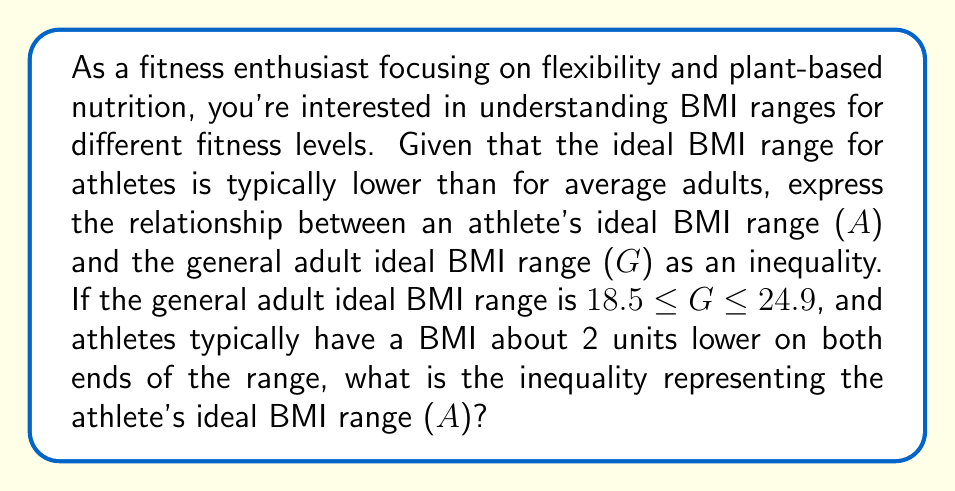Show me your answer to this math problem. Let's approach this step-by-step:

1) We're given that the general adult ideal BMI range is:
   $18.5 \leq G \leq 24.9$

2) We're told that athletes typically have a BMI about 2 units lower on both ends of the range.

3) To adjust the lower end of the range:
   $18.5 - 2 = 16.5$

4) To adjust the upper end of the range:
   $24.9 - 2 = 22.9$

5) Now we can construct the inequality for the athlete's ideal BMI range (A):
   $16.5 \leq A \leq 22.9$

This inequality represents the ideal BMI range for athletes, taking into account their typically lower BMI due to higher muscle mass and lower body fat percentage compared to the general population.
Answer: $16.5 \leq A \leq 22.9$ 